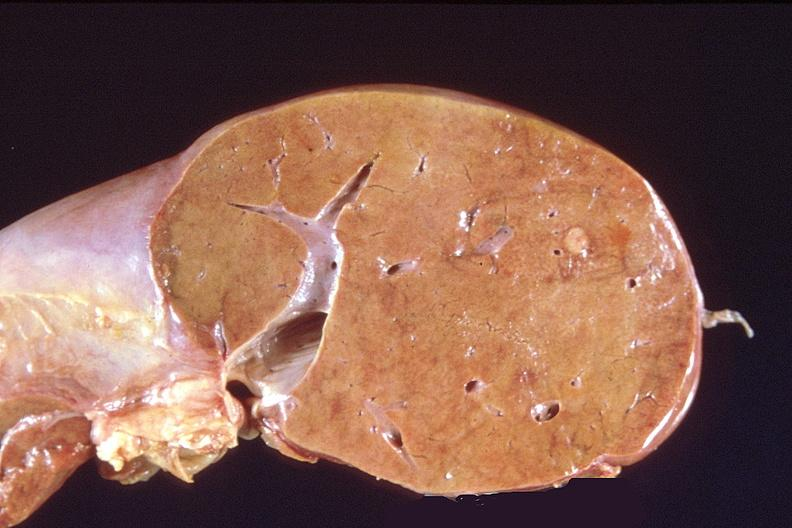does this image show liver, metastatic breast cancer?
Answer the question using a single word or phrase. Yes 